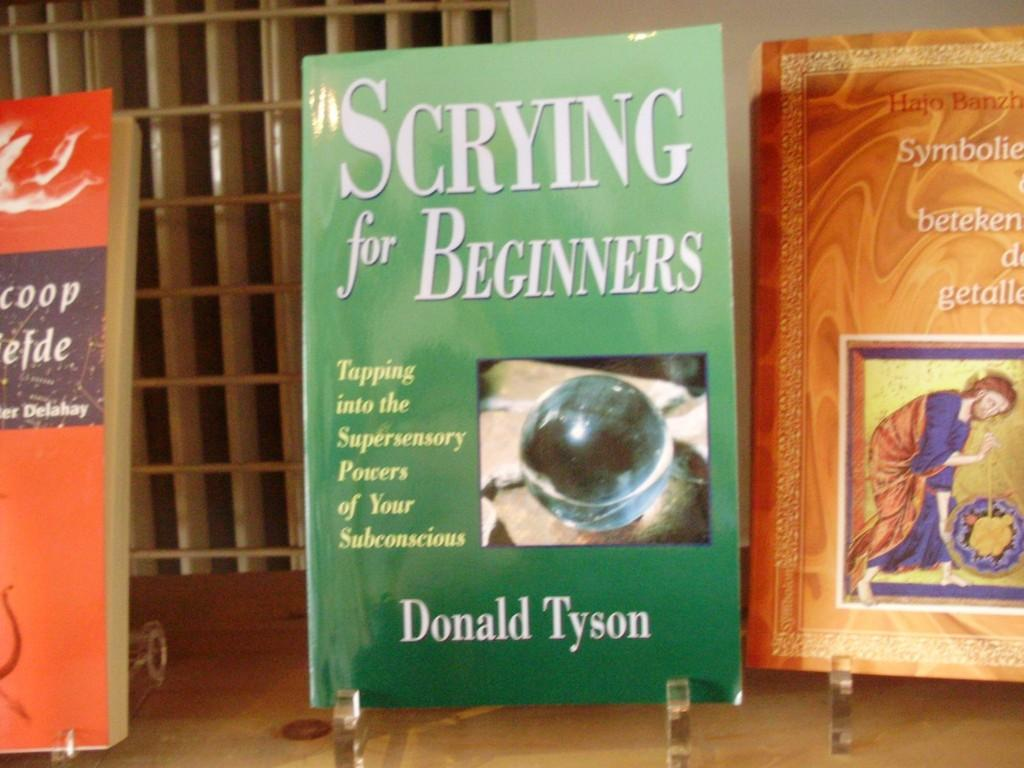<image>
Provide a brief description of the given image. Three books, one is written by Donald Tyson. 